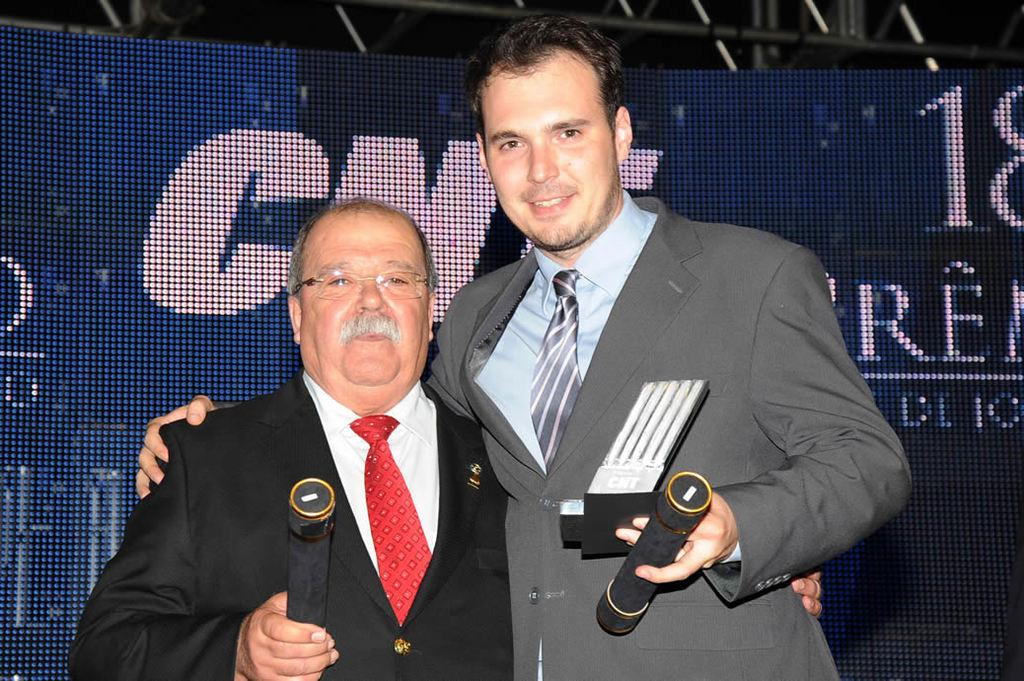How many people are present in the image? There are two persons standing in the image. What are the two persons holding in the image? The two persons are holding a microphone. Can you describe any other objects or features in the image? Yes, there is a screen visible in the image. What type of error can be seen on the screen in the image? There is no error visible on the screen in the image. What type of bubble is being used by the two persons in the image? There is no bubble present in the image; the two persons are holding a microphone. 